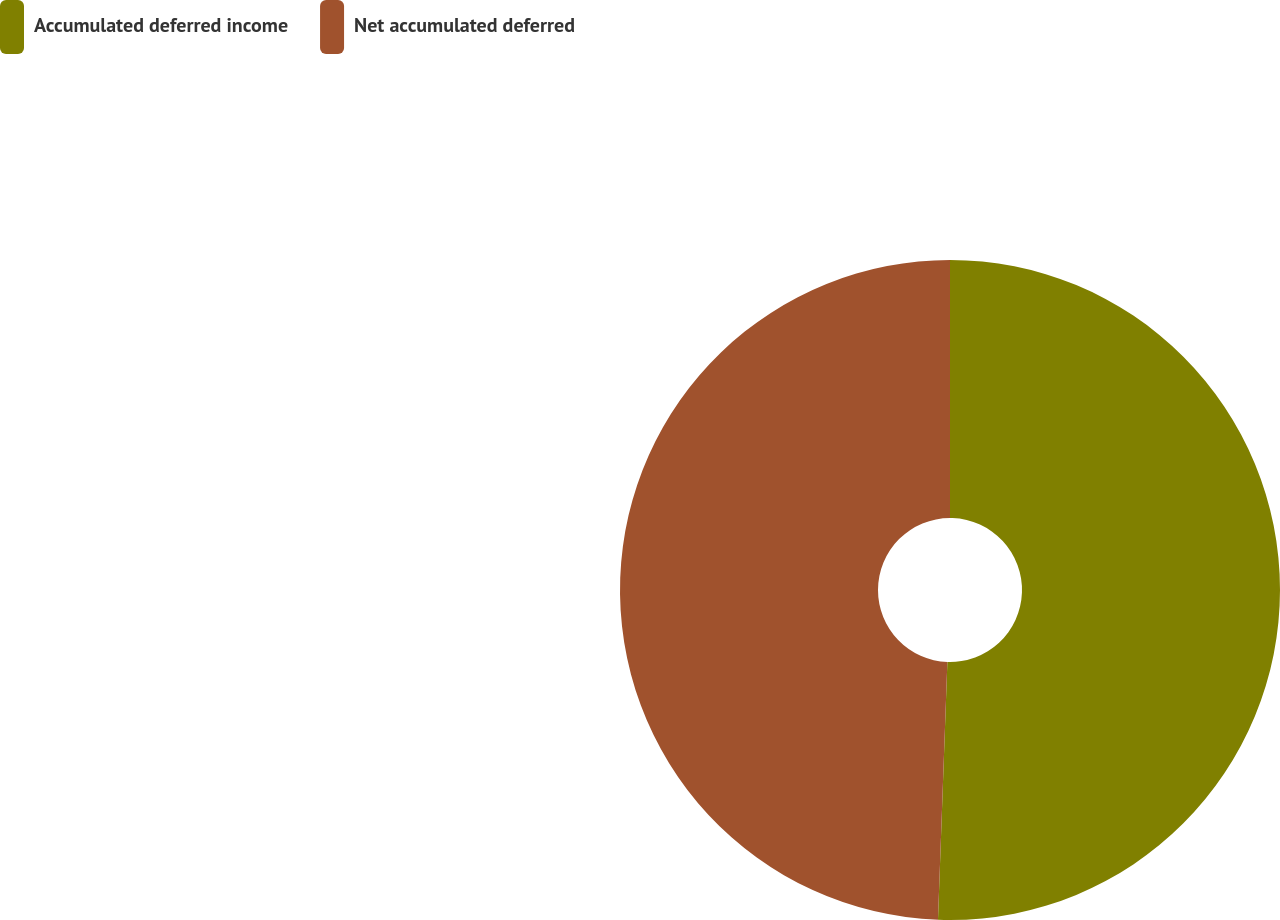<chart> <loc_0><loc_0><loc_500><loc_500><pie_chart><fcel>Accumulated deferred income<fcel>Net accumulated deferred<nl><fcel>50.58%<fcel>49.42%<nl></chart> 